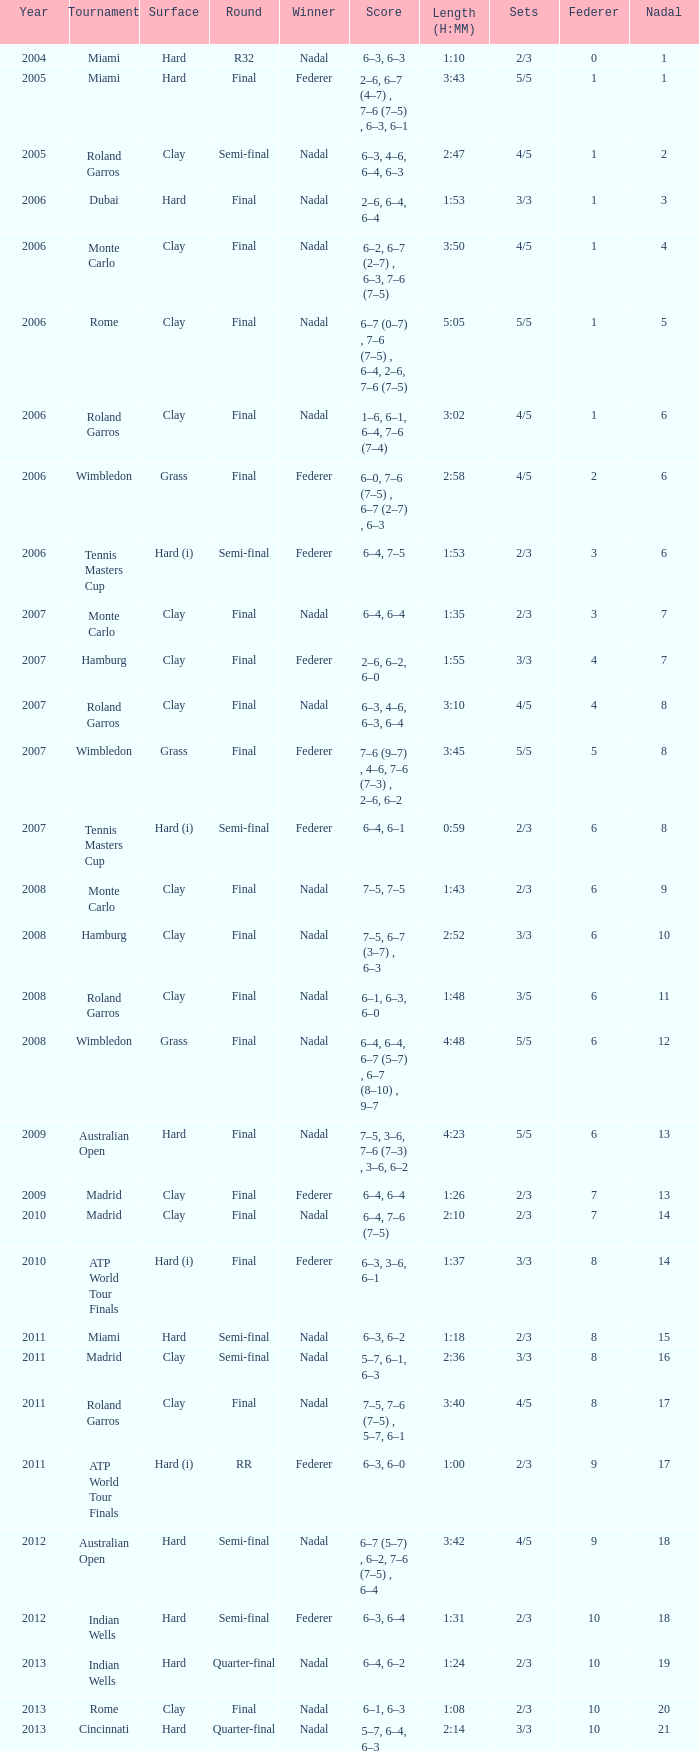What tournament did Nadal win and had a nadal of 16? Madrid. 